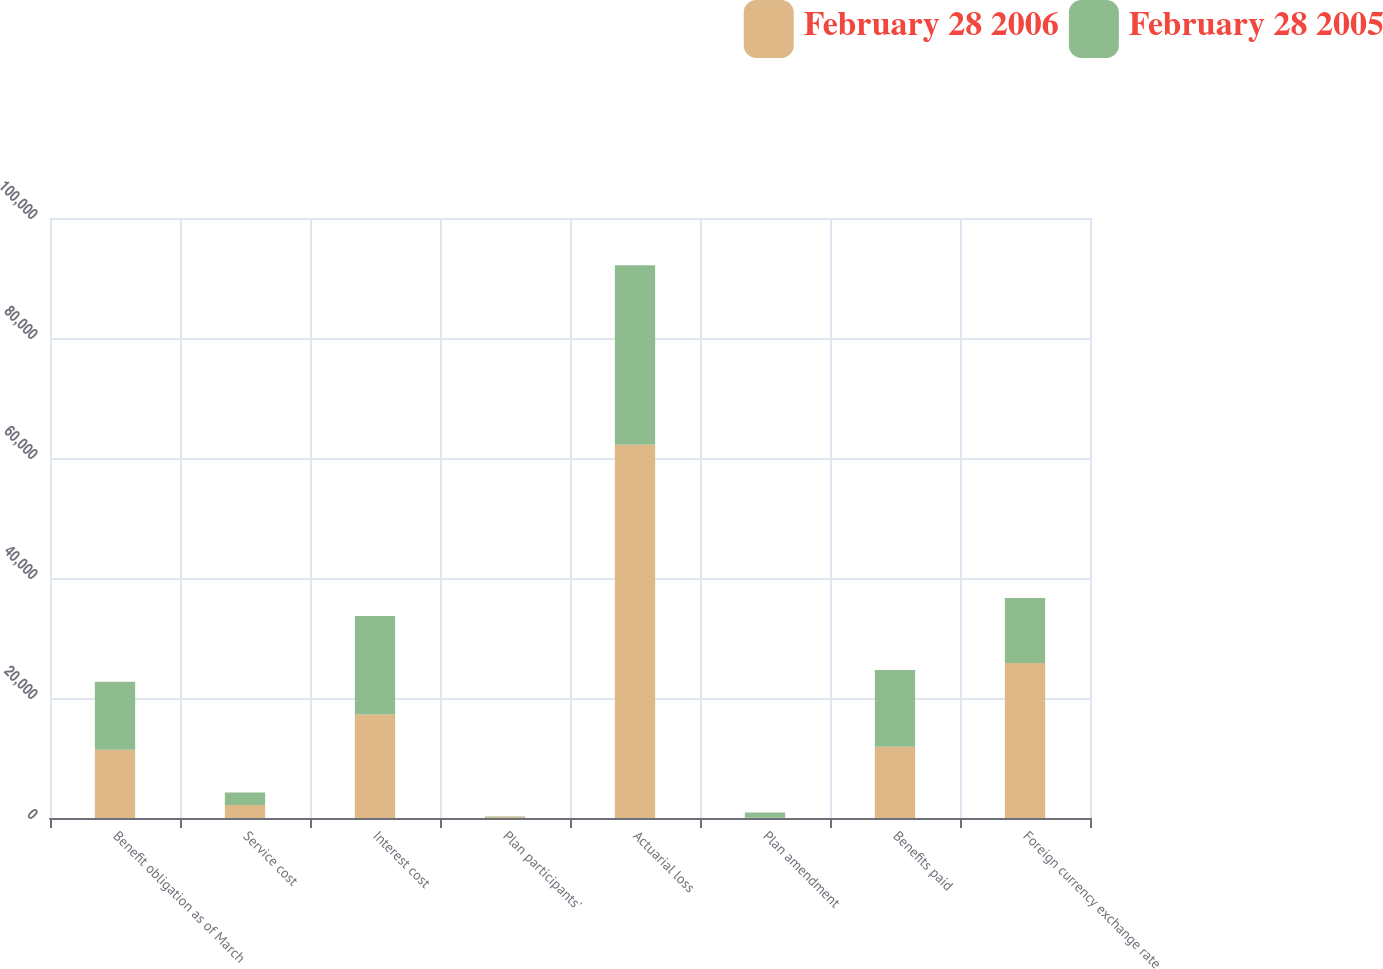<chart> <loc_0><loc_0><loc_500><loc_500><stacked_bar_chart><ecel><fcel>Benefit obligation as of March<fcel>Service cost<fcel>Interest cost<fcel>Plan participants'<fcel>Actuarial loss<fcel>Plan amendment<fcel>Benefits paid<fcel>Foreign currency exchange rate<nl><fcel>February 28 2006<fcel>11364.5<fcel>2149<fcel>17260<fcel>166<fcel>62194<fcel>38<fcel>11893<fcel>25837<nl><fcel>February 28 2005<fcel>11364.5<fcel>2117<fcel>16391<fcel>84<fcel>29939<fcel>884<fcel>12769<fcel>10836<nl></chart> 